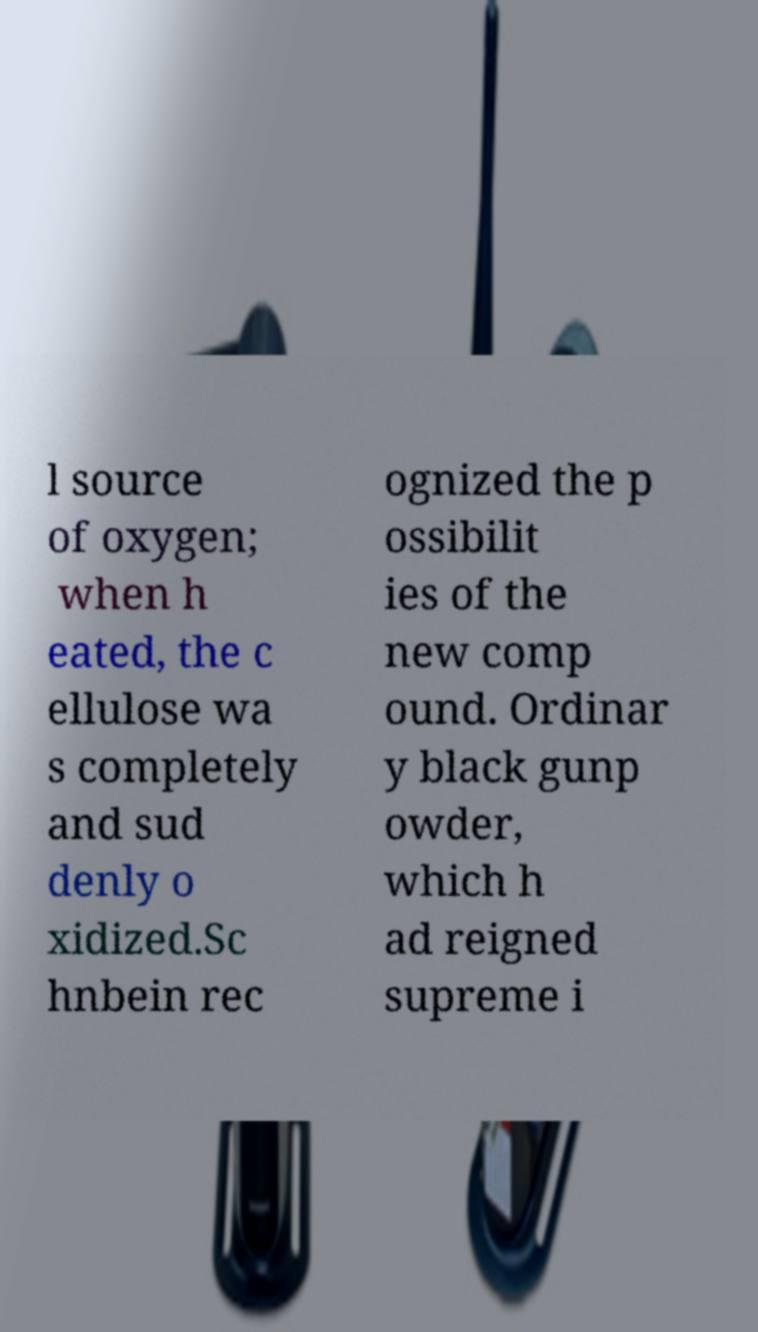Could you assist in decoding the text presented in this image and type it out clearly? l source of oxygen; when h eated, the c ellulose wa s completely and sud denly o xidized.Sc hnbein rec ognized the p ossibilit ies of the new comp ound. Ordinar y black gunp owder, which h ad reigned supreme i 